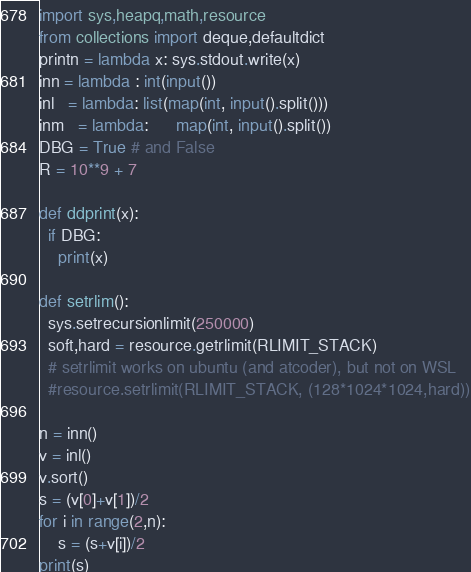Convert code to text. <code><loc_0><loc_0><loc_500><loc_500><_Python_>import sys,heapq,math,resource
from collections import deque,defaultdict
printn = lambda x: sys.stdout.write(x)
inn = lambda : int(input())
inl   = lambda: list(map(int, input().split()))
inm   = lambda:      map(int, input().split())
DBG = True # and False
R = 10**9 + 7

def ddprint(x):
  if DBG:
    print(x)

def setrlim():
  sys.setrecursionlimit(250000)
  soft,hard = resource.getrlimit(RLIMIT_STACK)
  # setrlimit works on ubuntu (and atcoder), but not on WSL
  #resource.setrlimit(RLIMIT_STACK, (128*1024*1024,hard))

n = inn()
v = inl()
v.sort()
s = (v[0]+v[1])/2
for i in range(2,n):
    s = (s+v[i])/2
print(s)
</code> 